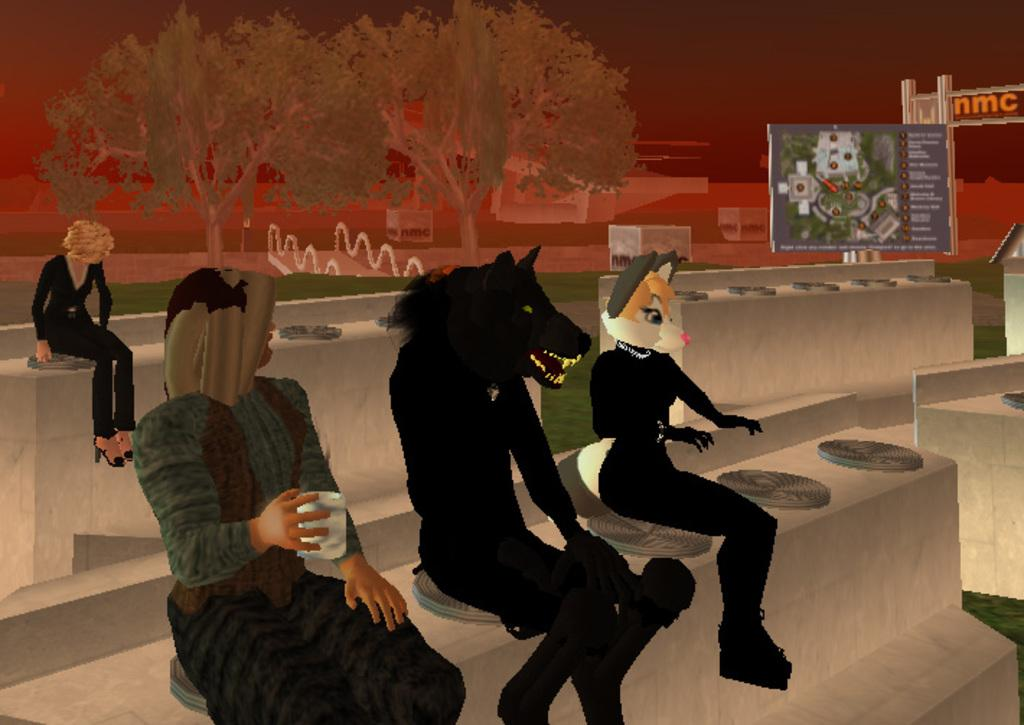What type of vegetation can be seen in the image? There are trees in the image. What else is present in the image besides the trees? There are banners in the image. What type of chicken can be seen in the image? There is no chicken present in the image. How many bananas are hanging from the trees in the image? There are no bananas present in the image, as it features trees and banners. 